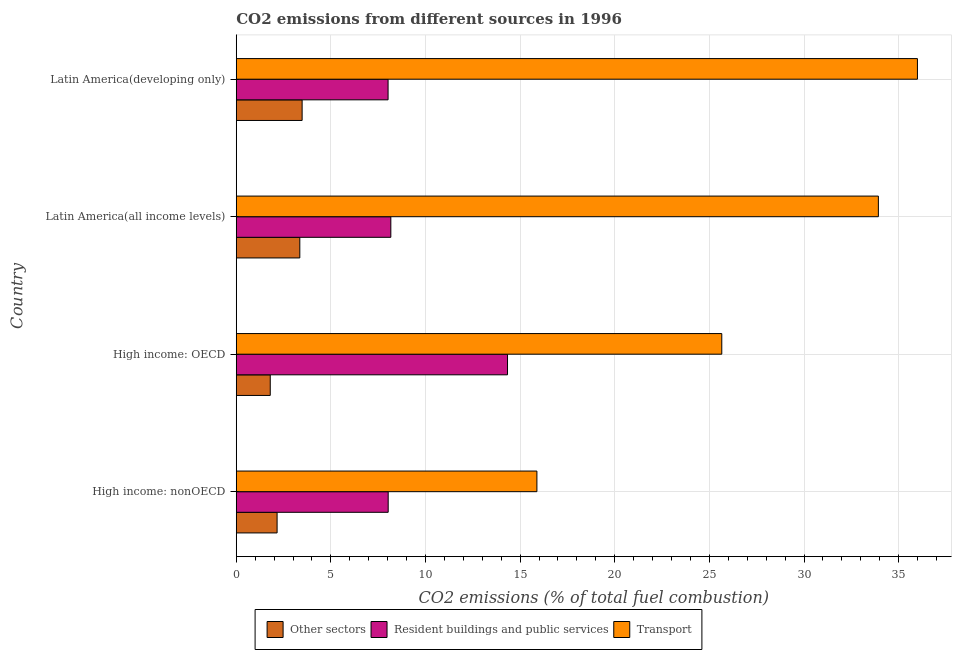How many groups of bars are there?
Give a very brief answer. 4. Are the number of bars per tick equal to the number of legend labels?
Make the answer very short. Yes. Are the number of bars on each tick of the Y-axis equal?
Your answer should be compact. Yes. How many bars are there on the 2nd tick from the bottom?
Your answer should be compact. 3. What is the label of the 1st group of bars from the top?
Offer a terse response. Latin America(developing only). What is the percentage of co2 emissions from other sectors in High income: OECD?
Your answer should be compact. 1.8. Across all countries, what is the maximum percentage of co2 emissions from transport?
Offer a terse response. 35.99. Across all countries, what is the minimum percentage of co2 emissions from resident buildings and public services?
Provide a succinct answer. 8.02. In which country was the percentage of co2 emissions from other sectors maximum?
Offer a very short reply. Latin America(developing only). In which country was the percentage of co2 emissions from transport minimum?
Your answer should be very brief. High income: nonOECD. What is the total percentage of co2 emissions from transport in the graph?
Your response must be concise. 111.47. What is the difference between the percentage of co2 emissions from other sectors in High income: nonOECD and that in Latin America(all income levels)?
Ensure brevity in your answer.  -1.2. What is the difference between the percentage of co2 emissions from transport in High income: OECD and the percentage of co2 emissions from other sectors in Latin America(all income levels)?
Provide a short and direct response. 22.3. What is the average percentage of co2 emissions from resident buildings and public services per country?
Provide a succinct answer. 9.64. What is the difference between the percentage of co2 emissions from other sectors and percentage of co2 emissions from resident buildings and public services in High income: nonOECD?
Your response must be concise. -5.87. What is the ratio of the percentage of co2 emissions from other sectors in High income: OECD to that in Latin America(developing only)?
Offer a terse response. 0.52. Is the difference between the percentage of co2 emissions from resident buildings and public services in High income: OECD and High income: nonOECD greater than the difference between the percentage of co2 emissions from other sectors in High income: OECD and High income: nonOECD?
Your answer should be very brief. Yes. What is the difference between the highest and the second highest percentage of co2 emissions from transport?
Your answer should be compact. 2.06. What is the difference between the highest and the lowest percentage of co2 emissions from transport?
Offer a terse response. 20.11. In how many countries, is the percentage of co2 emissions from transport greater than the average percentage of co2 emissions from transport taken over all countries?
Provide a succinct answer. 2. What does the 3rd bar from the top in Latin America(all income levels) represents?
Your answer should be compact. Other sectors. What does the 2nd bar from the bottom in High income: OECD represents?
Offer a very short reply. Resident buildings and public services. How many bars are there?
Give a very brief answer. 12. How many countries are there in the graph?
Your answer should be compact. 4. Are the values on the major ticks of X-axis written in scientific E-notation?
Make the answer very short. No. Does the graph contain any zero values?
Offer a terse response. No. How many legend labels are there?
Keep it short and to the point. 3. What is the title of the graph?
Offer a terse response. CO2 emissions from different sources in 1996. What is the label or title of the X-axis?
Your answer should be very brief. CO2 emissions (% of total fuel combustion). What is the label or title of the Y-axis?
Provide a short and direct response. Country. What is the CO2 emissions (% of total fuel combustion) of Other sectors in High income: nonOECD?
Give a very brief answer. 2.16. What is the CO2 emissions (% of total fuel combustion) of Resident buildings and public services in High income: nonOECD?
Offer a very short reply. 8.03. What is the CO2 emissions (% of total fuel combustion) in Transport in High income: nonOECD?
Give a very brief answer. 15.89. What is the CO2 emissions (% of total fuel combustion) in Other sectors in High income: OECD?
Offer a terse response. 1.8. What is the CO2 emissions (% of total fuel combustion) in Resident buildings and public services in High income: OECD?
Give a very brief answer. 14.33. What is the CO2 emissions (% of total fuel combustion) of Transport in High income: OECD?
Offer a terse response. 25.66. What is the CO2 emissions (% of total fuel combustion) in Other sectors in Latin America(all income levels)?
Offer a very short reply. 3.36. What is the CO2 emissions (% of total fuel combustion) of Resident buildings and public services in Latin America(all income levels)?
Keep it short and to the point. 8.17. What is the CO2 emissions (% of total fuel combustion) in Transport in Latin America(all income levels)?
Provide a succinct answer. 33.93. What is the CO2 emissions (% of total fuel combustion) of Other sectors in Latin America(developing only)?
Your answer should be compact. 3.48. What is the CO2 emissions (% of total fuel combustion) in Resident buildings and public services in Latin America(developing only)?
Your response must be concise. 8.02. What is the CO2 emissions (% of total fuel combustion) in Transport in Latin America(developing only)?
Provide a succinct answer. 35.99. Across all countries, what is the maximum CO2 emissions (% of total fuel combustion) of Other sectors?
Your answer should be compact. 3.48. Across all countries, what is the maximum CO2 emissions (% of total fuel combustion) in Resident buildings and public services?
Give a very brief answer. 14.33. Across all countries, what is the maximum CO2 emissions (% of total fuel combustion) of Transport?
Make the answer very short. 35.99. Across all countries, what is the minimum CO2 emissions (% of total fuel combustion) in Other sectors?
Ensure brevity in your answer.  1.8. Across all countries, what is the minimum CO2 emissions (% of total fuel combustion) in Resident buildings and public services?
Your response must be concise. 8.02. Across all countries, what is the minimum CO2 emissions (% of total fuel combustion) in Transport?
Provide a short and direct response. 15.89. What is the total CO2 emissions (% of total fuel combustion) of Other sectors in the graph?
Your response must be concise. 10.79. What is the total CO2 emissions (% of total fuel combustion) of Resident buildings and public services in the graph?
Provide a succinct answer. 38.55. What is the total CO2 emissions (% of total fuel combustion) of Transport in the graph?
Ensure brevity in your answer.  111.47. What is the difference between the CO2 emissions (% of total fuel combustion) of Other sectors in High income: nonOECD and that in High income: OECD?
Provide a short and direct response. 0.36. What is the difference between the CO2 emissions (% of total fuel combustion) of Resident buildings and public services in High income: nonOECD and that in High income: OECD?
Give a very brief answer. -6.31. What is the difference between the CO2 emissions (% of total fuel combustion) of Transport in High income: nonOECD and that in High income: OECD?
Ensure brevity in your answer.  -9.77. What is the difference between the CO2 emissions (% of total fuel combustion) of Other sectors in High income: nonOECD and that in Latin America(all income levels)?
Make the answer very short. -1.2. What is the difference between the CO2 emissions (% of total fuel combustion) in Resident buildings and public services in High income: nonOECD and that in Latin America(all income levels)?
Provide a short and direct response. -0.14. What is the difference between the CO2 emissions (% of total fuel combustion) in Transport in High income: nonOECD and that in Latin America(all income levels)?
Your answer should be very brief. -18.04. What is the difference between the CO2 emissions (% of total fuel combustion) of Other sectors in High income: nonOECD and that in Latin America(developing only)?
Offer a terse response. -1.32. What is the difference between the CO2 emissions (% of total fuel combustion) of Resident buildings and public services in High income: nonOECD and that in Latin America(developing only)?
Provide a short and direct response. 0.01. What is the difference between the CO2 emissions (% of total fuel combustion) in Transport in High income: nonOECD and that in Latin America(developing only)?
Keep it short and to the point. -20.11. What is the difference between the CO2 emissions (% of total fuel combustion) in Other sectors in High income: OECD and that in Latin America(all income levels)?
Give a very brief answer. -1.56. What is the difference between the CO2 emissions (% of total fuel combustion) in Resident buildings and public services in High income: OECD and that in Latin America(all income levels)?
Your answer should be very brief. 6.17. What is the difference between the CO2 emissions (% of total fuel combustion) in Transport in High income: OECD and that in Latin America(all income levels)?
Your answer should be very brief. -8.27. What is the difference between the CO2 emissions (% of total fuel combustion) of Other sectors in High income: OECD and that in Latin America(developing only)?
Ensure brevity in your answer.  -1.68. What is the difference between the CO2 emissions (% of total fuel combustion) of Resident buildings and public services in High income: OECD and that in Latin America(developing only)?
Your answer should be compact. 6.31. What is the difference between the CO2 emissions (% of total fuel combustion) in Transport in High income: OECD and that in Latin America(developing only)?
Give a very brief answer. -10.34. What is the difference between the CO2 emissions (% of total fuel combustion) of Other sectors in Latin America(all income levels) and that in Latin America(developing only)?
Offer a very short reply. -0.12. What is the difference between the CO2 emissions (% of total fuel combustion) in Resident buildings and public services in Latin America(all income levels) and that in Latin America(developing only)?
Provide a short and direct response. 0.15. What is the difference between the CO2 emissions (% of total fuel combustion) in Transport in Latin America(all income levels) and that in Latin America(developing only)?
Ensure brevity in your answer.  -2.06. What is the difference between the CO2 emissions (% of total fuel combustion) in Other sectors in High income: nonOECD and the CO2 emissions (% of total fuel combustion) in Resident buildings and public services in High income: OECD?
Provide a short and direct response. -12.18. What is the difference between the CO2 emissions (% of total fuel combustion) of Other sectors in High income: nonOECD and the CO2 emissions (% of total fuel combustion) of Transport in High income: OECD?
Offer a terse response. -23.5. What is the difference between the CO2 emissions (% of total fuel combustion) of Resident buildings and public services in High income: nonOECD and the CO2 emissions (% of total fuel combustion) of Transport in High income: OECD?
Offer a terse response. -17.63. What is the difference between the CO2 emissions (% of total fuel combustion) of Other sectors in High income: nonOECD and the CO2 emissions (% of total fuel combustion) of Resident buildings and public services in Latin America(all income levels)?
Provide a short and direct response. -6.01. What is the difference between the CO2 emissions (% of total fuel combustion) of Other sectors in High income: nonOECD and the CO2 emissions (% of total fuel combustion) of Transport in Latin America(all income levels)?
Offer a very short reply. -31.77. What is the difference between the CO2 emissions (% of total fuel combustion) of Resident buildings and public services in High income: nonOECD and the CO2 emissions (% of total fuel combustion) of Transport in Latin America(all income levels)?
Ensure brevity in your answer.  -25.9. What is the difference between the CO2 emissions (% of total fuel combustion) of Other sectors in High income: nonOECD and the CO2 emissions (% of total fuel combustion) of Resident buildings and public services in Latin America(developing only)?
Provide a succinct answer. -5.86. What is the difference between the CO2 emissions (% of total fuel combustion) in Other sectors in High income: nonOECD and the CO2 emissions (% of total fuel combustion) in Transport in Latin America(developing only)?
Ensure brevity in your answer.  -33.84. What is the difference between the CO2 emissions (% of total fuel combustion) of Resident buildings and public services in High income: nonOECD and the CO2 emissions (% of total fuel combustion) of Transport in Latin America(developing only)?
Keep it short and to the point. -27.97. What is the difference between the CO2 emissions (% of total fuel combustion) in Other sectors in High income: OECD and the CO2 emissions (% of total fuel combustion) in Resident buildings and public services in Latin America(all income levels)?
Make the answer very short. -6.37. What is the difference between the CO2 emissions (% of total fuel combustion) of Other sectors in High income: OECD and the CO2 emissions (% of total fuel combustion) of Transport in Latin America(all income levels)?
Your answer should be very brief. -32.13. What is the difference between the CO2 emissions (% of total fuel combustion) of Resident buildings and public services in High income: OECD and the CO2 emissions (% of total fuel combustion) of Transport in Latin America(all income levels)?
Provide a succinct answer. -19.6. What is the difference between the CO2 emissions (% of total fuel combustion) in Other sectors in High income: OECD and the CO2 emissions (% of total fuel combustion) in Resident buildings and public services in Latin America(developing only)?
Provide a succinct answer. -6.23. What is the difference between the CO2 emissions (% of total fuel combustion) of Other sectors in High income: OECD and the CO2 emissions (% of total fuel combustion) of Transport in Latin America(developing only)?
Offer a terse response. -34.2. What is the difference between the CO2 emissions (% of total fuel combustion) in Resident buildings and public services in High income: OECD and the CO2 emissions (% of total fuel combustion) in Transport in Latin America(developing only)?
Give a very brief answer. -21.66. What is the difference between the CO2 emissions (% of total fuel combustion) of Other sectors in Latin America(all income levels) and the CO2 emissions (% of total fuel combustion) of Resident buildings and public services in Latin America(developing only)?
Make the answer very short. -4.66. What is the difference between the CO2 emissions (% of total fuel combustion) of Other sectors in Latin America(all income levels) and the CO2 emissions (% of total fuel combustion) of Transport in Latin America(developing only)?
Give a very brief answer. -32.64. What is the difference between the CO2 emissions (% of total fuel combustion) of Resident buildings and public services in Latin America(all income levels) and the CO2 emissions (% of total fuel combustion) of Transport in Latin America(developing only)?
Give a very brief answer. -27.83. What is the average CO2 emissions (% of total fuel combustion) in Other sectors per country?
Give a very brief answer. 2.7. What is the average CO2 emissions (% of total fuel combustion) of Resident buildings and public services per country?
Keep it short and to the point. 9.64. What is the average CO2 emissions (% of total fuel combustion) of Transport per country?
Give a very brief answer. 27.87. What is the difference between the CO2 emissions (% of total fuel combustion) of Other sectors and CO2 emissions (% of total fuel combustion) of Resident buildings and public services in High income: nonOECD?
Give a very brief answer. -5.87. What is the difference between the CO2 emissions (% of total fuel combustion) in Other sectors and CO2 emissions (% of total fuel combustion) in Transport in High income: nonOECD?
Provide a short and direct response. -13.73. What is the difference between the CO2 emissions (% of total fuel combustion) of Resident buildings and public services and CO2 emissions (% of total fuel combustion) of Transport in High income: nonOECD?
Offer a terse response. -7.86. What is the difference between the CO2 emissions (% of total fuel combustion) in Other sectors and CO2 emissions (% of total fuel combustion) in Resident buildings and public services in High income: OECD?
Keep it short and to the point. -12.54. What is the difference between the CO2 emissions (% of total fuel combustion) in Other sectors and CO2 emissions (% of total fuel combustion) in Transport in High income: OECD?
Your answer should be very brief. -23.86. What is the difference between the CO2 emissions (% of total fuel combustion) in Resident buildings and public services and CO2 emissions (% of total fuel combustion) in Transport in High income: OECD?
Ensure brevity in your answer.  -11.32. What is the difference between the CO2 emissions (% of total fuel combustion) of Other sectors and CO2 emissions (% of total fuel combustion) of Resident buildings and public services in Latin America(all income levels)?
Your answer should be very brief. -4.81. What is the difference between the CO2 emissions (% of total fuel combustion) in Other sectors and CO2 emissions (% of total fuel combustion) in Transport in Latin America(all income levels)?
Keep it short and to the point. -30.57. What is the difference between the CO2 emissions (% of total fuel combustion) in Resident buildings and public services and CO2 emissions (% of total fuel combustion) in Transport in Latin America(all income levels)?
Your answer should be very brief. -25.76. What is the difference between the CO2 emissions (% of total fuel combustion) in Other sectors and CO2 emissions (% of total fuel combustion) in Resident buildings and public services in Latin America(developing only)?
Offer a very short reply. -4.54. What is the difference between the CO2 emissions (% of total fuel combustion) of Other sectors and CO2 emissions (% of total fuel combustion) of Transport in Latin America(developing only)?
Provide a succinct answer. -32.51. What is the difference between the CO2 emissions (% of total fuel combustion) in Resident buildings and public services and CO2 emissions (% of total fuel combustion) in Transport in Latin America(developing only)?
Provide a succinct answer. -27.97. What is the ratio of the CO2 emissions (% of total fuel combustion) in Other sectors in High income: nonOECD to that in High income: OECD?
Offer a terse response. 1.2. What is the ratio of the CO2 emissions (% of total fuel combustion) in Resident buildings and public services in High income: nonOECD to that in High income: OECD?
Your answer should be compact. 0.56. What is the ratio of the CO2 emissions (% of total fuel combustion) in Transport in High income: nonOECD to that in High income: OECD?
Give a very brief answer. 0.62. What is the ratio of the CO2 emissions (% of total fuel combustion) in Other sectors in High income: nonOECD to that in Latin America(all income levels)?
Give a very brief answer. 0.64. What is the ratio of the CO2 emissions (% of total fuel combustion) of Resident buildings and public services in High income: nonOECD to that in Latin America(all income levels)?
Your response must be concise. 0.98. What is the ratio of the CO2 emissions (% of total fuel combustion) of Transport in High income: nonOECD to that in Latin America(all income levels)?
Your answer should be compact. 0.47. What is the ratio of the CO2 emissions (% of total fuel combustion) in Other sectors in High income: nonOECD to that in Latin America(developing only)?
Give a very brief answer. 0.62. What is the ratio of the CO2 emissions (% of total fuel combustion) of Resident buildings and public services in High income: nonOECD to that in Latin America(developing only)?
Offer a terse response. 1. What is the ratio of the CO2 emissions (% of total fuel combustion) in Transport in High income: nonOECD to that in Latin America(developing only)?
Your answer should be very brief. 0.44. What is the ratio of the CO2 emissions (% of total fuel combustion) in Other sectors in High income: OECD to that in Latin America(all income levels)?
Ensure brevity in your answer.  0.54. What is the ratio of the CO2 emissions (% of total fuel combustion) of Resident buildings and public services in High income: OECD to that in Latin America(all income levels)?
Your answer should be very brief. 1.75. What is the ratio of the CO2 emissions (% of total fuel combustion) in Transport in High income: OECD to that in Latin America(all income levels)?
Provide a short and direct response. 0.76. What is the ratio of the CO2 emissions (% of total fuel combustion) of Other sectors in High income: OECD to that in Latin America(developing only)?
Offer a very short reply. 0.52. What is the ratio of the CO2 emissions (% of total fuel combustion) in Resident buildings and public services in High income: OECD to that in Latin America(developing only)?
Your response must be concise. 1.79. What is the ratio of the CO2 emissions (% of total fuel combustion) in Transport in High income: OECD to that in Latin America(developing only)?
Keep it short and to the point. 0.71. What is the ratio of the CO2 emissions (% of total fuel combustion) in Other sectors in Latin America(all income levels) to that in Latin America(developing only)?
Ensure brevity in your answer.  0.96. What is the ratio of the CO2 emissions (% of total fuel combustion) of Resident buildings and public services in Latin America(all income levels) to that in Latin America(developing only)?
Give a very brief answer. 1.02. What is the ratio of the CO2 emissions (% of total fuel combustion) in Transport in Latin America(all income levels) to that in Latin America(developing only)?
Make the answer very short. 0.94. What is the difference between the highest and the second highest CO2 emissions (% of total fuel combustion) in Other sectors?
Give a very brief answer. 0.12. What is the difference between the highest and the second highest CO2 emissions (% of total fuel combustion) in Resident buildings and public services?
Keep it short and to the point. 6.17. What is the difference between the highest and the second highest CO2 emissions (% of total fuel combustion) of Transport?
Keep it short and to the point. 2.06. What is the difference between the highest and the lowest CO2 emissions (% of total fuel combustion) of Other sectors?
Your response must be concise. 1.68. What is the difference between the highest and the lowest CO2 emissions (% of total fuel combustion) in Resident buildings and public services?
Make the answer very short. 6.31. What is the difference between the highest and the lowest CO2 emissions (% of total fuel combustion) in Transport?
Your answer should be compact. 20.11. 